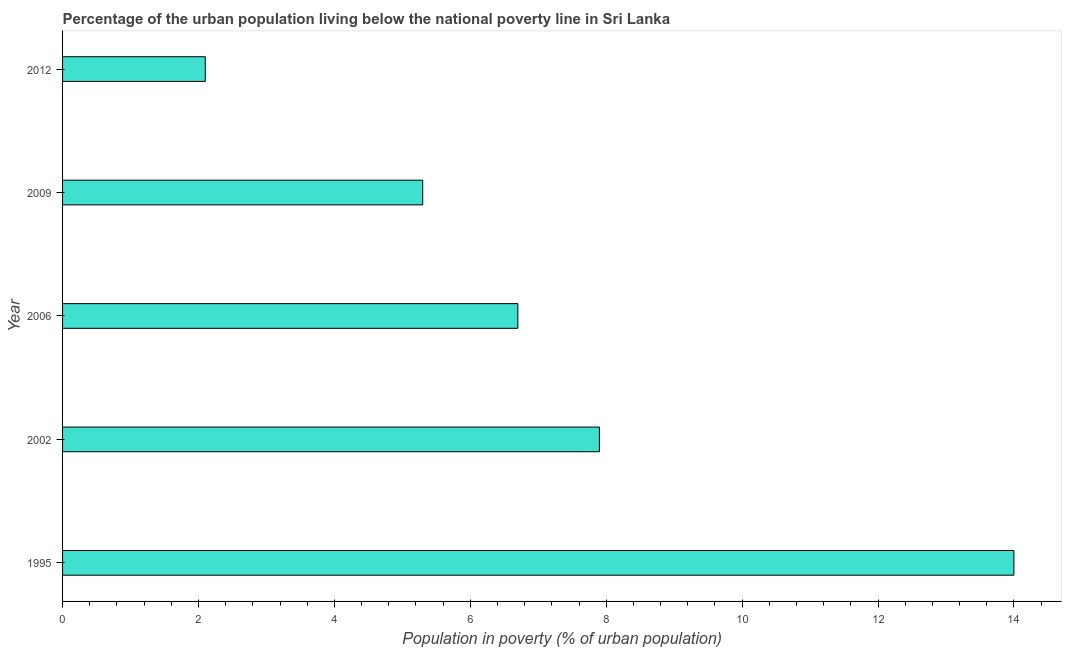Does the graph contain any zero values?
Offer a terse response. No. Does the graph contain grids?
Make the answer very short. No. What is the title of the graph?
Give a very brief answer. Percentage of the urban population living below the national poverty line in Sri Lanka. What is the label or title of the X-axis?
Your answer should be compact. Population in poverty (% of urban population). In which year was the percentage of urban population living below poverty line minimum?
Make the answer very short. 2012. What is the difference between the percentage of urban population living below poverty line in 2002 and 2009?
Your answer should be very brief. 2.6. What is the median percentage of urban population living below poverty line?
Ensure brevity in your answer.  6.7. In how many years, is the percentage of urban population living below poverty line greater than 2.4 %?
Offer a terse response. 4. What is the ratio of the percentage of urban population living below poverty line in 1995 to that in 2002?
Provide a short and direct response. 1.77. Is the difference between the percentage of urban population living below poverty line in 1995 and 2006 greater than the difference between any two years?
Offer a very short reply. No. What is the difference between the highest and the second highest percentage of urban population living below poverty line?
Offer a terse response. 6.1. What is the difference between the highest and the lowest percentage of urban population living below poverty line?
Ensure brevity in your answer.  11.9. In how many years, is the percentage of urban population living below poverty line greater than the average percentage of urban population living below poverty line taken over all years?
Ensure brevity in your answer.  2. Are all the bars in the graph horizontal?
Offer a terse response. Yes. How many years are there in the graph?
Your response must be concise. 5. What is the difference between two consecutive major ticks on the X-axis?
Your answer should be very brief. 2. Are the values on the major ticks of X-axis written in scientific E-notation?
Your answer should be very brief. No. What is the Population in poverty (% of urban population) in 2002?
Provide a short and direct response. 7.9. What is the Population in poverty (% of urban population) in 2012?
Offer a terse response. 2.1. What is the difference between the Population in poverty (% of urban population) in 1995 and 2006?
Keep it short and to the point. 7.3. What is the difference between the Population in poverty (% of urban population) in 1995 and 2012?
Your response must be concise. 11.9. What is the difference between the Population in poverty (% of urban population) in 2002 and 2012?
Keep it short and to the point. 5.8. What is the difference between the Population in poverty (% of urban population) in 2006 and 2009?
Make the answer very short. 1.4. What is the difference between the Population in poverty (% of urban population) in 2006 and 2012?
Provide a succinct answer. 4.6. What is the difference between the Population in poverty (% of urban population) in 2009 and 2012?
Keep it short and to the point. 3.2. What is the ratio of the Population in poverty (% of urban population) in 1995 to that in 2002?
Ensure brevity in your answer.  1.77. What is the ratio of the Population in poverty (% of urban population) in 1995 to that in 2006?
Your answer should be very brief. 2.09. What is the ratio of the Population in poverty (% of urban population) in 1995 to that in 2009?
Your response must be concise. 2.64. What is the ratio of the Population in poverty (% of urban population) in 1995 to that in 2012?
Make the answer very short. 6.67. What is the ratio of the Population in poverty (% of urban population) in 2002 to that in 2006?
Your answer should be compact. 1.18. What is the ratio of the Population in poverty (% of urban population) in 2002 to that in 2009?
Your response must be concise. 1.49. What is the ratio of the Population in poverty (% of urban population) in 2002 to that in 2012?
Your response must be concise. 3.76. What is the ratio of the Population in poverty (% of urban population) in 2006 to that in 2009?
Keep it short and to the point. 1.26. What is the ratio of the Population in poverty (% of urban population) in 2006 to that in 2012?
Provide a short and direct response. 3.19. What is the ratio of the Population in poverty (% of urban population) in 2009 to that in 2012?
Provide a succinct answer. 2.52. 